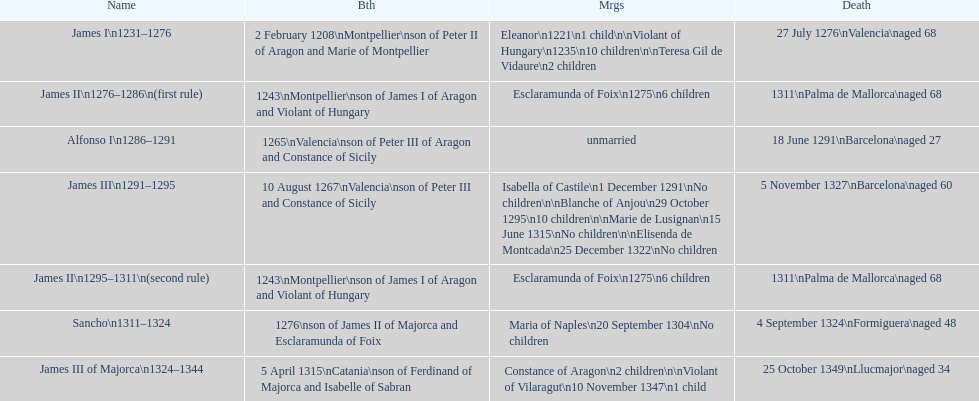Which monarch is listed first? James I 1231-1276. Parse the table in full. {'header': ['Name', 'Bth', 'Mrgs', 'Death'], 'rows': [['James I\\n1231–1276', '2 February 1208\\nMontpellier\\nson of Peter II of Aragon and Marie of Montpellier', 'Eleanor\\n1221\\n1 child\\n\\nViolant of Hungary\\n1235\\n10 children\\n\\nTeresa Gil de Vidaure\\n2 children', '27 July 1276\\nValencia\\naged 68'], ['James II\\n1276–1286\\n(first rule)', '1243\\nMontpellier\\nson of James I of Aragon and Violant of Hungary', 'Esclaramunda of Foix\\n1275\\n6 children', '1311\\nPalma de Mallorca\\naged 68'], ['Alfonso I\\n1286–1291', '1265\\nValencia\\nson of Peter III of Aragon and Constance of Sicily', 'unmarried', '18 June 1291\\nBarcelona\\naged 27'], ['James III\\n1291–1295', '10 August 1267\\nValencia\\nson of Peter III and Constance of Sicily', 'Isabella of Castile\\n1 December 1291\\nNo children\\n\\nBlanche of Anjou\\n29 October 1295\\n10 children\\n\\nMarie de Lusignan\\n15 June 1315\\nNo children\\n\\nElisenda de Montcada\\n25 December 1322\\nNo children', '5 November 1327\\nBarcelona\\naged 60'], ['James II\\n1295–1311\\n(second rule)', '1243\\nMontpellier\\nson of James I of Aragon and Violant of Hungary', 'Esclaramunda of Foix\\n1275\\n6 children', '1311\\nPalma de Mallorca\\naged 68'], ['Sancho\\n1311–1324', '1276\\nson of James II of Majorca and Esclaramunda of Foix', 'Maria of Naples\\n20 September 1304\\nNo children', '4 September 1324\\nFormiguera\\naged 48'], ['James III of Majorca\\n1324–1344', '5 April 1315\\nCatania\\nson of Ferdinand of Majorca and Isabelle of Sabran', 'Constance of Aragon\\n2 children\\n\\nViolant of Vilaragut\\n10 November 1347\\n1 child', '25 October 1349\\nLlucmajor\\naged 34']]} 